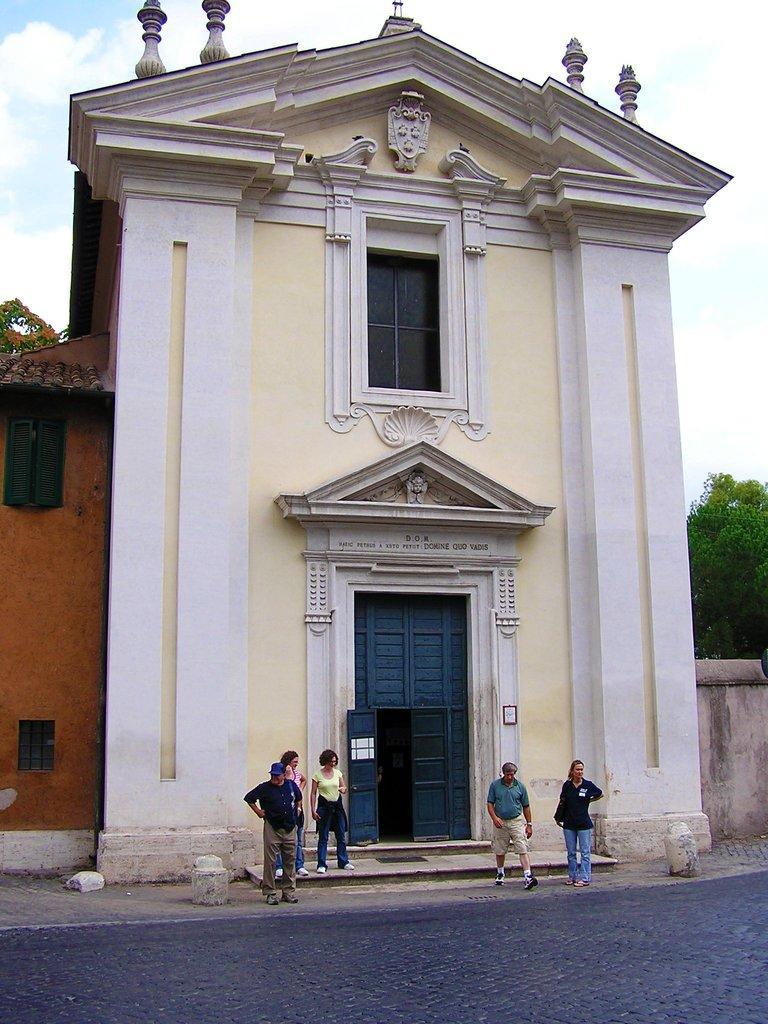Can you describe this image briefly? This image consists of building in the middle. There are trees on the right side. There are some persons standing at the bottom. There is door in the middle. There is sky at the top. 